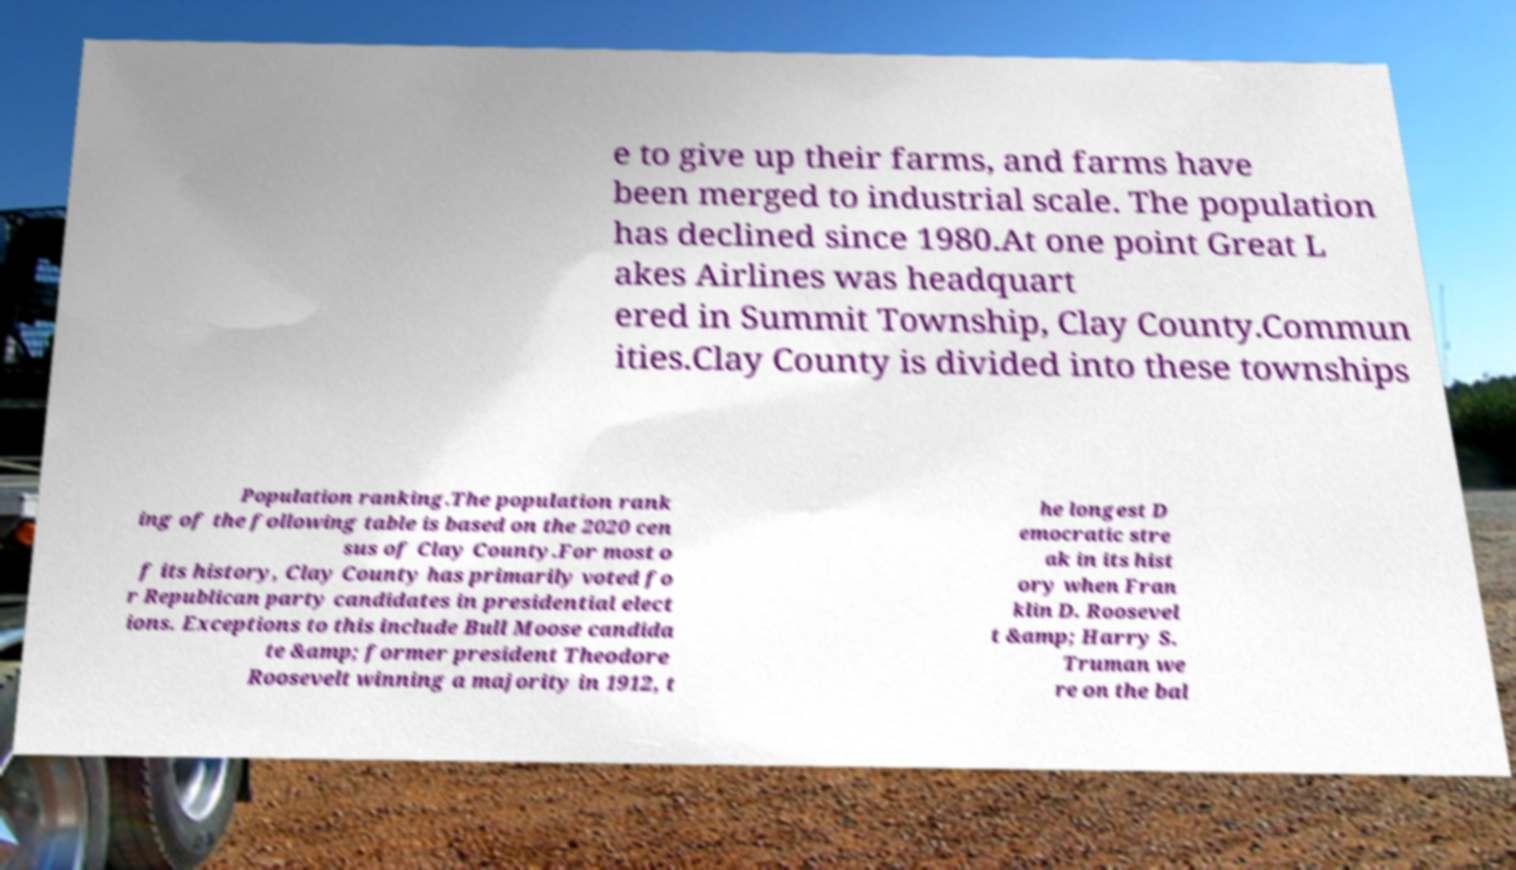Could you extract and type out the text from this image? e to give up their farms, and farms have been merged to industrial scale. The population has declined since 1980.At one point Great L akes Airlines was headquart ered in Summit Township, Clay County.Commun ities.Clay County is divided into these townships Population ranking.The population rank ing of the following table is based on the 2020 cen sus of Clay County.For most o f its history, Clay County has primarily voted fo r Republican party candidates in presidential elect ions. Exceptions to this include Bull Moose candida te &amp; former president Theodore Roosevelt winning a majority in 1912, t he longest D emocratic stre ak in its hist ory when Fran klin D. Roosevel t &amp; Harry S. Truman we re on the bal 